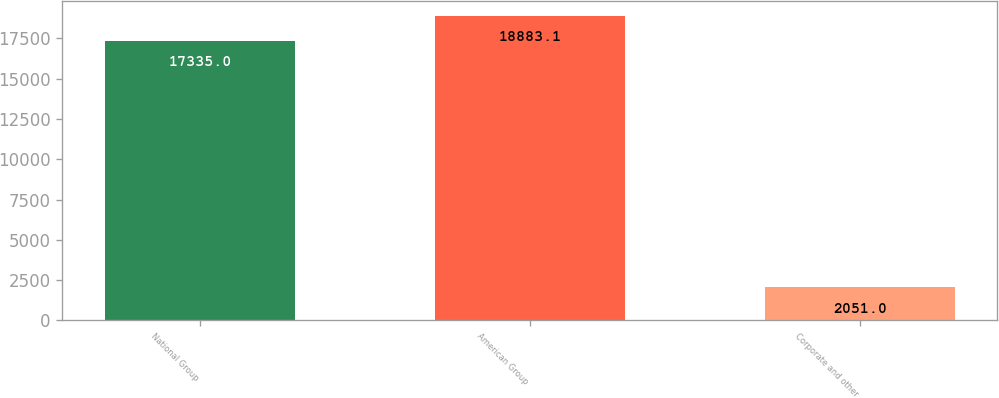Convert chart. <chart><loc_0><loc_0><loc_500><loc_500><bar_chart><fcel>National Group<fcel>American Group<fcel>Corporate and other<nl><fcel>17335<fcel>18883.1<fcel>2051<nl></chart> 